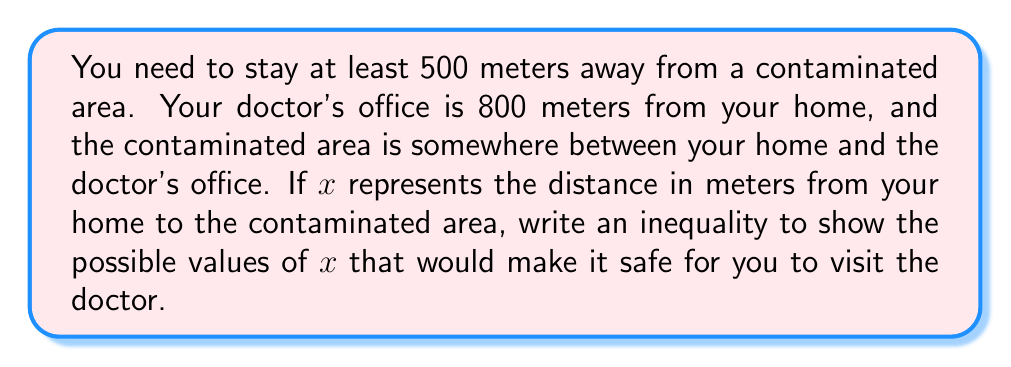Can you answer this question? Let's approach this step-by-step:

1) We know that $x$ represents the distance from your home to the contaminated area.

2) The total distance from your home to the doctor's office is 800 meters.

3) You need to stay at least 500 meters away from the contaminated area.

4) For it to be safe to visit the doctor, you need to be at least 500 meters away from the contaminated area at all points of your journey.

5) This means:
   a) The contaminated area should be at least 500 meters away from your home: $x \geq 500$
   b) The contaminated area should be at least 500 meters away from the doctor's office: $800 - x \geq 500$

6) From the second condition, we can derive: $800 - 500 \geq x$ or $300 \geq x$

7) Combining both conditions, we get:

   $500 \leq x \leq 300$

8) However, this is impossible because $x$ cannot be greater than or equal to 500 and less than or equal to 300 at the same time.

9) This means there is no safe value for $x$. In other words, it's not safe to visit the doctor under these conditions.
Answer: There is no solution. The inequality $500 \leq x \leq 300$ has no valid solutions, meaning it's not safe to visit the doctor under the given conditions. 